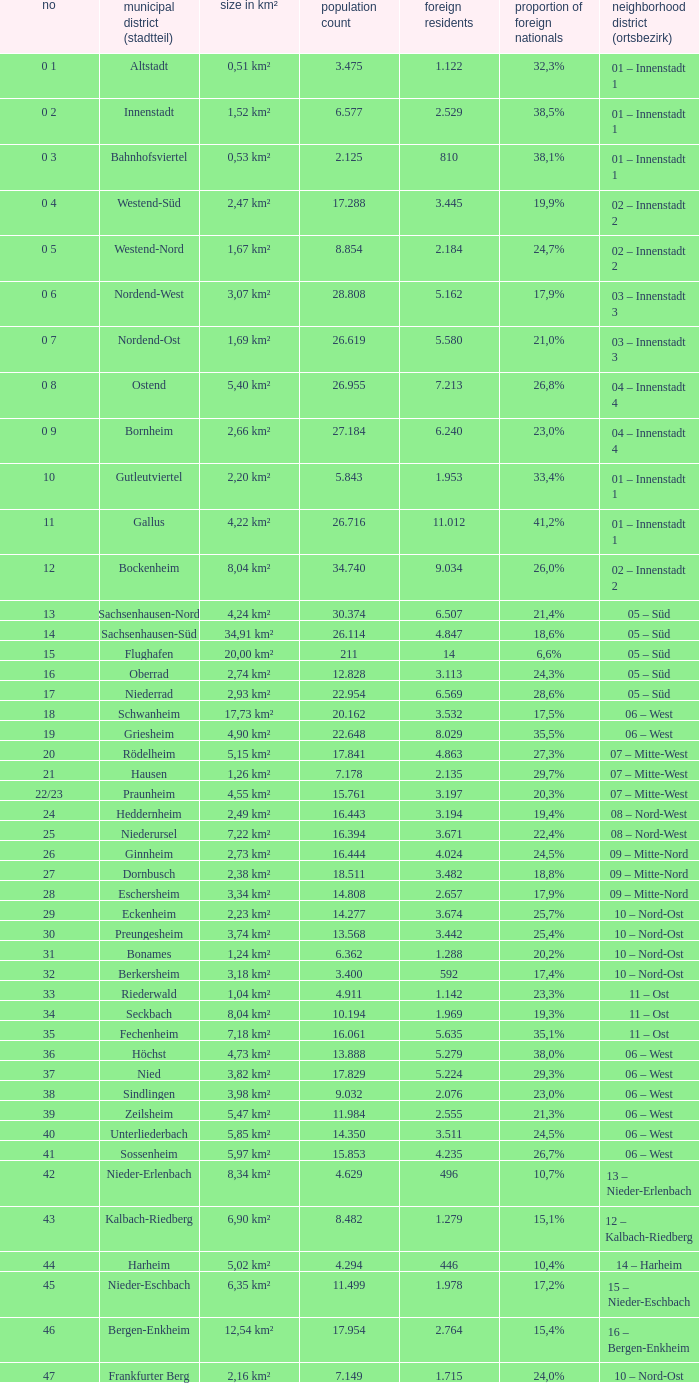What is the city where the number is 47? Frankfurter Berg. 